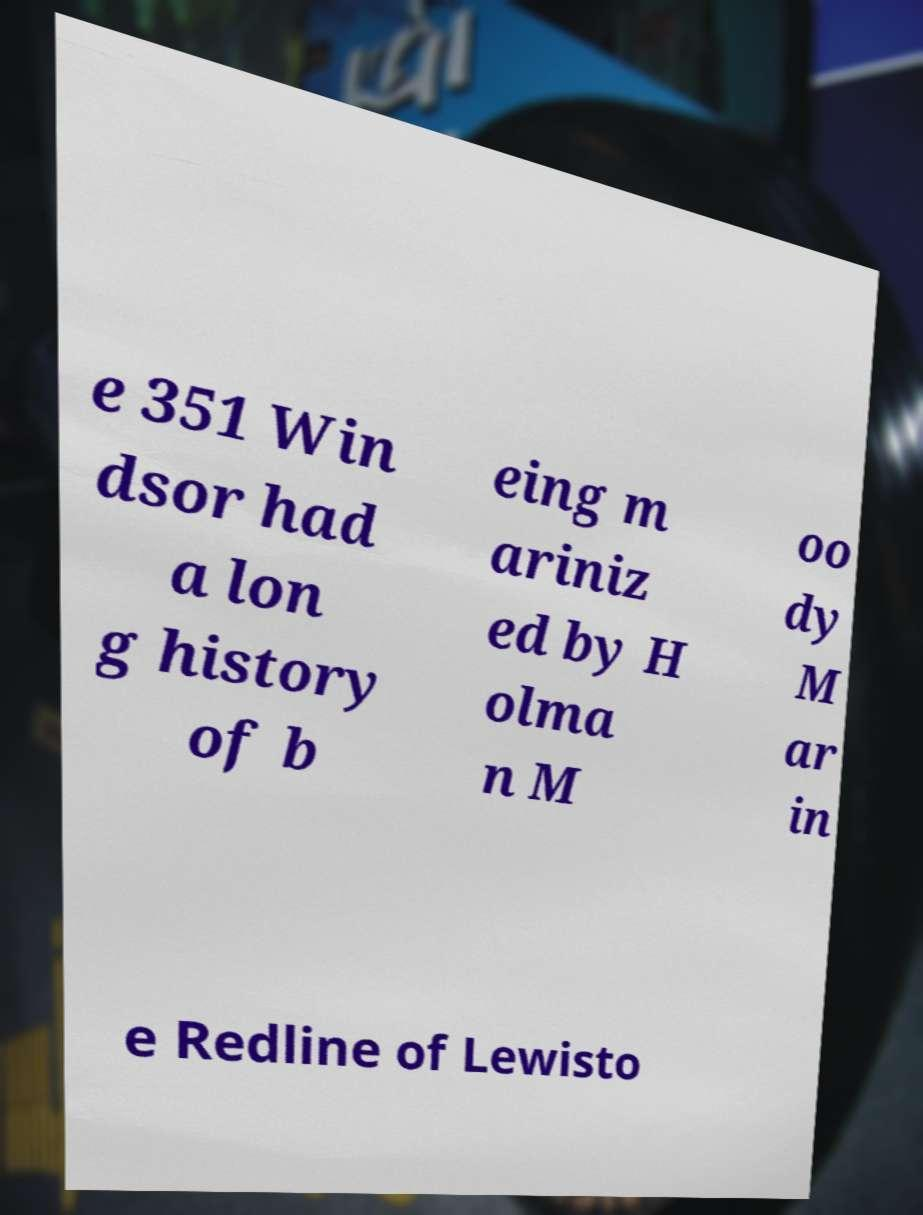I need the written content from this picture converted into text. Can you do that? e 351 Win dsor had a lon g history of b eing m ariniz ed by H olma n M oo dy M ar in e Redline of Lewisto 